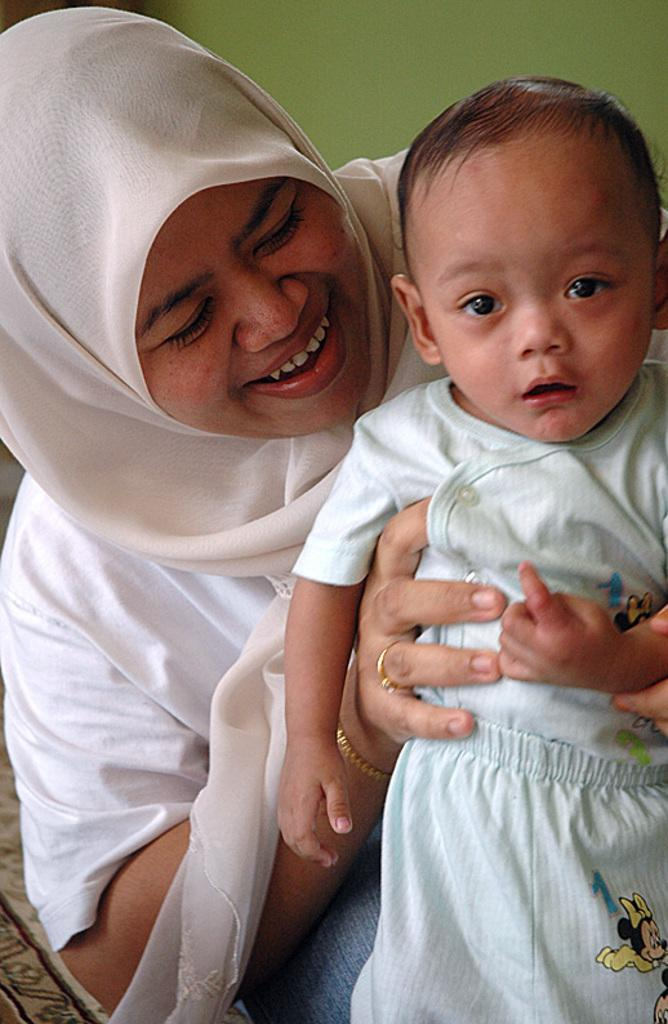Who is present in the image? There is a woman in the image. What is the woman doing in the image? The woman is holding a child. What can be observed about the child's attire? The child is wearing clothes. What type of farm animals can be seen in the image? There are no farm animals present in the image. What is the child using to keep warm in the image? The provided facts do not mention a scarf or any other item used for warmth, and the child's clothing is not described in detail. 